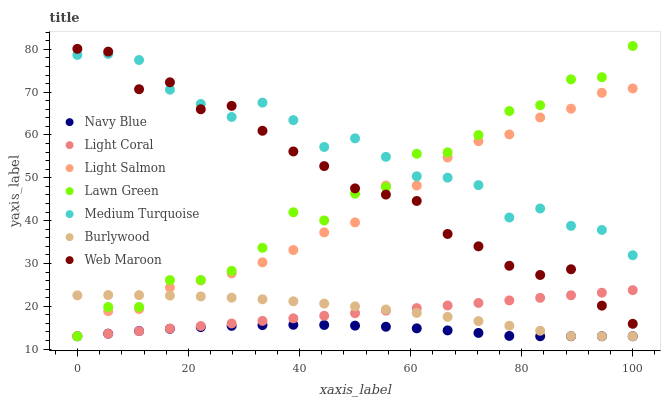Does Navy Blue have the minimum area under the curve?
Answer yes or no. Yes. Does Medium Turquoise have the maximum area under the curve?
Answer yes or no. Yes. Does Light Salmon have the minimum area under the curve?
Answer yes or no. No. Does Light Salmon have the maximum area under the curve?
Answer yes or no. No. Is Light Coral the smoothest?
Answer yes or no. Yes. Is Lawn Green the roughest?
Answer yes or no. Yes. Is Light Salmon the smoothest?
Answer yes or no. No. Is Light Salmon the roughest?
Answer yes or no. No. Does Lawn Green have the lowest value?
Answer yes or no. Yes. Does Web Maroon have the lowest value?
Answer yes or no. No. Does Lawn Green have the highest value?
Answer yes or no. Yes. Does Light Salmon have the highest value?
Answer yes or no. No. Is Navy Blue less than Web Maroon?
Answer yes or no. Yes. Is Web Maroon greater than Navy Blue?
Answer yes or no. Yes. Does Light Salmon intersect Light Coral?
Answer yes or no. Yes. Is Light Salmon less than Light Coral?
Answer yes or no. No. Is Light Salmon greater than Light Coral?
Answer yes or no. No. Does Navy Blue intersect Web Maroon?
Answer yes or no. No. 